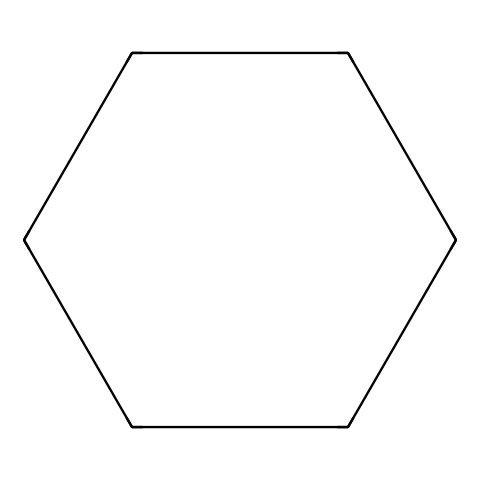What is the molecular formula of cyclohexane? The SMILES representation indicates the presence of 6 carbon atoms (C) and 12 hydrogen atoms (H) in the structure. Therefore, the molecular formula can be derived as C6H12.
Answer: C6H12 How many carbon atoms are in cyclohexane? The chemical structure reveals a total of 6 vertices, each representing a carbon atom in the cyclohexane molecule. Therefore, the number of carbon atoms is 6.
Answer: 6 What type of chemical structure does cyclohexane represent? Cyclohexane consists of a ring of carbon atoms connected by single bonds, making it a cycloalkane, which is characterized specifically by its ring structure.
Answer: cycloalkane How many hydrogen atoms are connected to each carbon in cyclohexane? Each carbon in cyclohexane is typically bonded to two hydrogen atoms in this saturated structure, which accounts for the total of 12 hydrogen atoms for the six carbon atoms.
Answer: 2 What kind of bonding is present in cyclohexane? Cyclohexane exclusively contains single covalent bonds connecting the carbon atoms to one another and to the hydrogen atoms, distinguishing it as a saturated hydrocarbon.
Answer: single bonds Why is cyclohexane considered a good solvent in eco-friendly cleaning solutions? Cyclohexane's non-polar nature allows it to effectively dissolve non-polar substances, making it suitable for cleaning applications where non-polar stains or greases need to be removed.
Answer: non-polar solvent What is the significance of the cyclic structure in cyclohexane? The cyclic structure allows for more stability compared to linear alkanes of similar molecular weight and can lead to specific interactions with surfactants, enhancing cleaning efficacy.
Answer: stability 